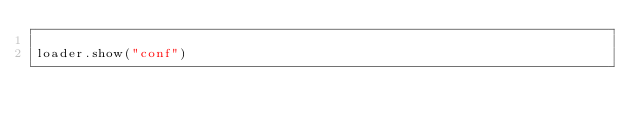<code> <loc_0><loc_0><loc_500><loc_500><_Python_>
loader.show("conf")
</code> 